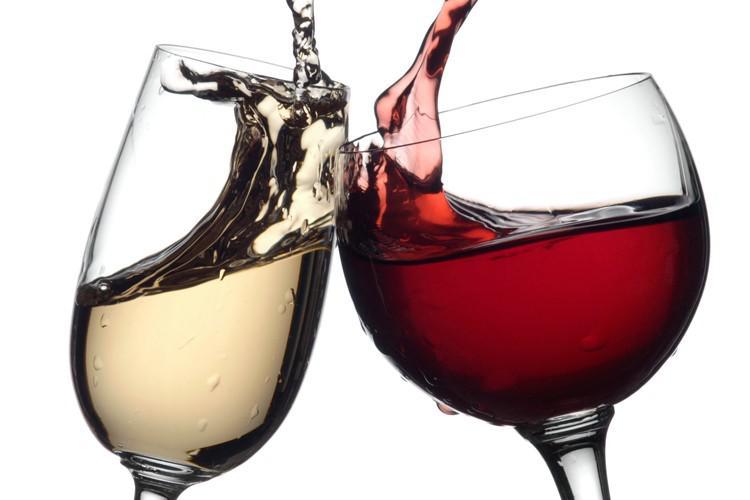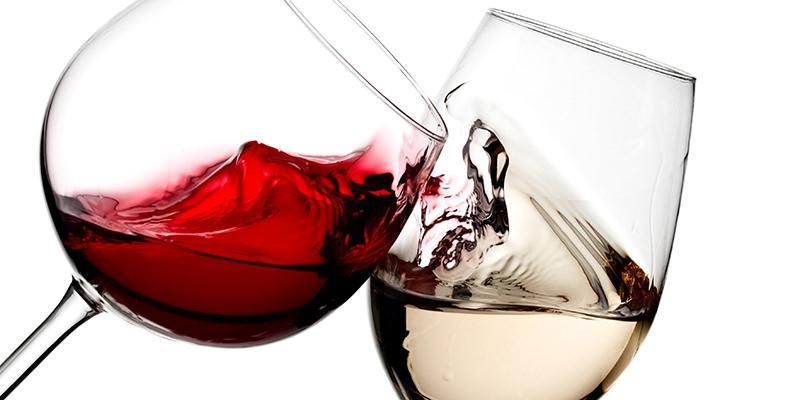The first image is the image on the left, the second image is the image on the right. Analyze the images presented: Is the assertion "In one image, two glasses of wine are sitting before at least one bottle." valid? Answer yes or no. No. 